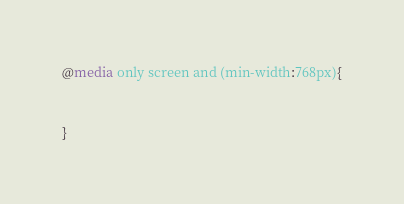Convert code to text. <code><loc_0><loc_0><loc_500><loc_500><_CSS_>@media only screen and (min-width:768px){


}
</code> 